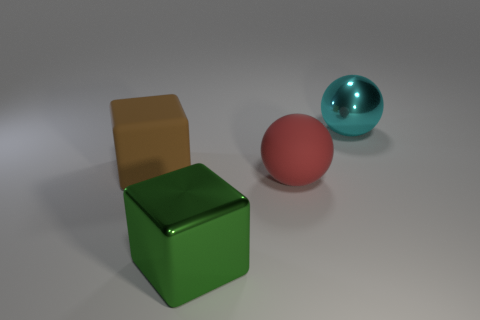Add 2 yellow metal cubes. How many objects exist? 6 Subtract all small blue matte blocks. Subtract all large shiny things. How many objects are left? 2 Add 2 cyan spheres. How many cyan spheres are left? 3 Add 4 large green metallic objects. How many large green metallic objects exist? 5 Subtract 1 brown cubes. How many objects are left? 3 